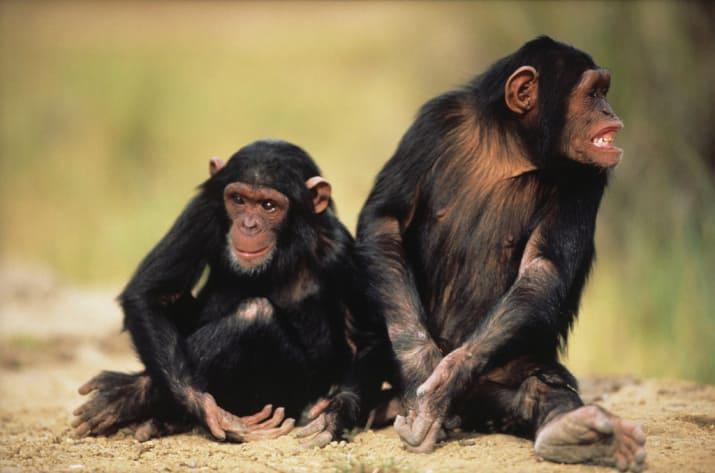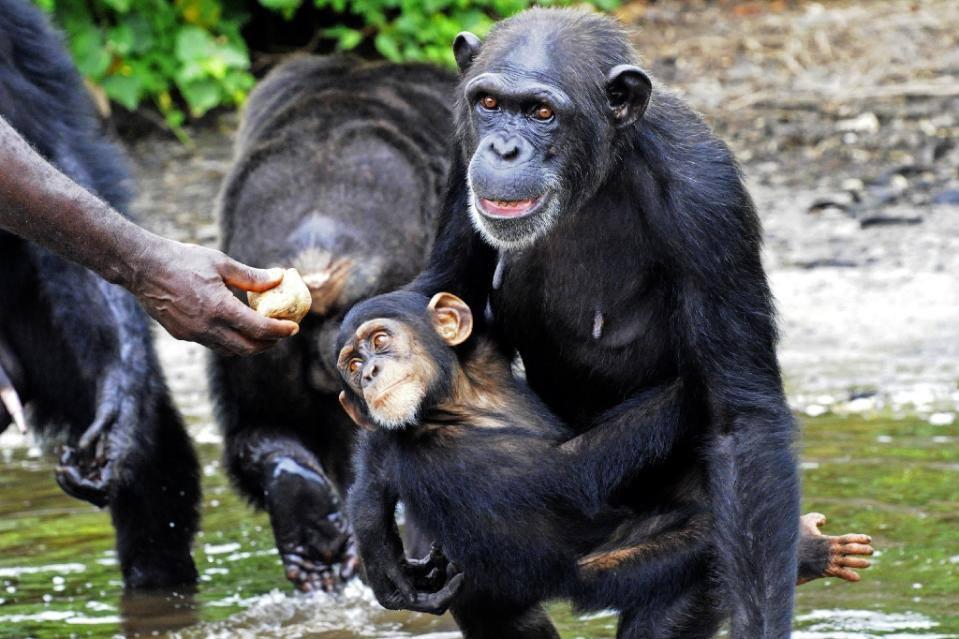The first image is the image on the left, the second image is the image on the right. Evaluate the accuracy of this statement regarding the images: "A baboon is carrying a baby baboon in the image on the right.". Is it true? Answer yes or no. Yes. The first image is the image on the left, the second image is the image on the right. For the images displayed, is the sentence "An image contains exactly two chimps, and both chimps are sitting on the ground." factually correct? Answer yes or no. Yes. 